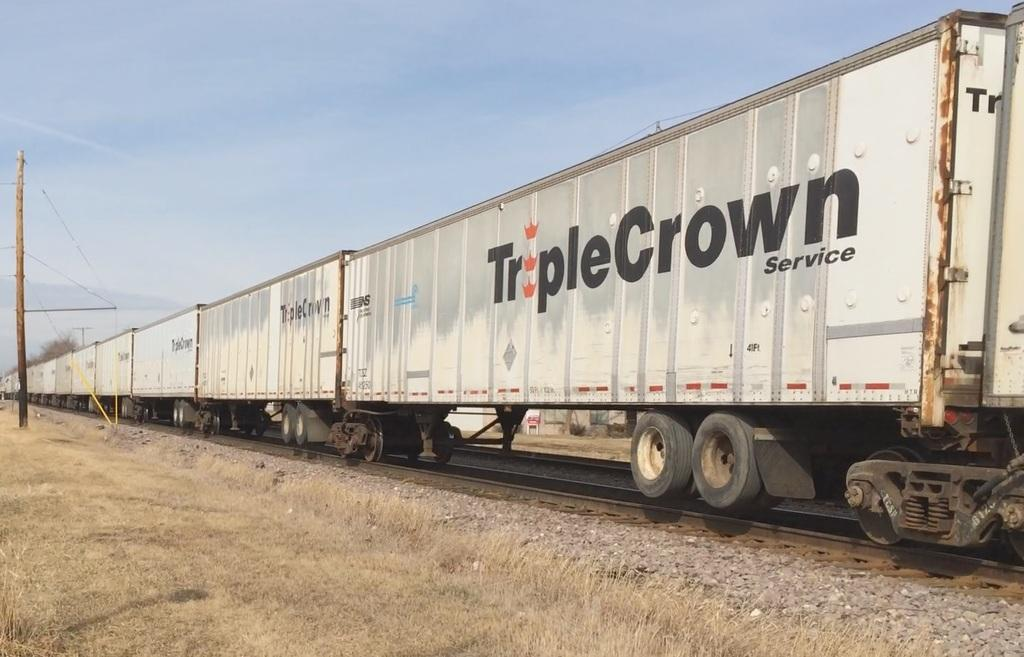<image>
Present a compact description of the photo's key features. A bunch of train cars that read Triple Crown. 